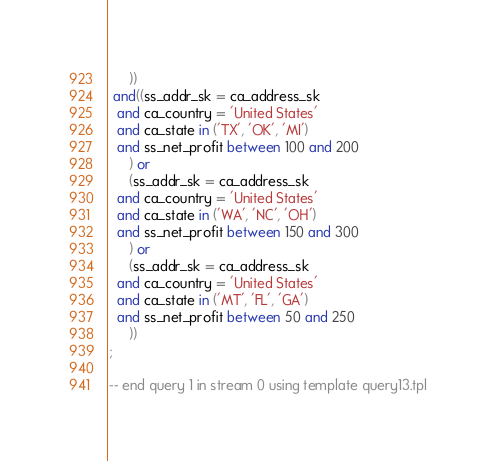<code> <loc_0><loc_0><loc_500><loc_500><_SQL_>     ))
 and((ss_addr_sk = ca_address_sk
  and ca_country = 'United States'
  and ca_state in ('TX', 'OK', 'MI')
  and ss_net_profit between 100 and 200  
     ) or
     (ss_addr_sk = ca_address_sk
  and ca_country = 'United States'
  and ca_state in ('WA', 'NC', 'OH')
  and ss_net_profit between 150 and 300  
     ) or
     (ss_addr_sk = ca_address_sk
  and ca_country = 'United States'
  and ca_state in ('MT', 'FL', 'GA')
  and ss_net_profit between 50 and 250  
     ))
;

-- end query 1 in stream 0 using template query13.tpl
</code> 